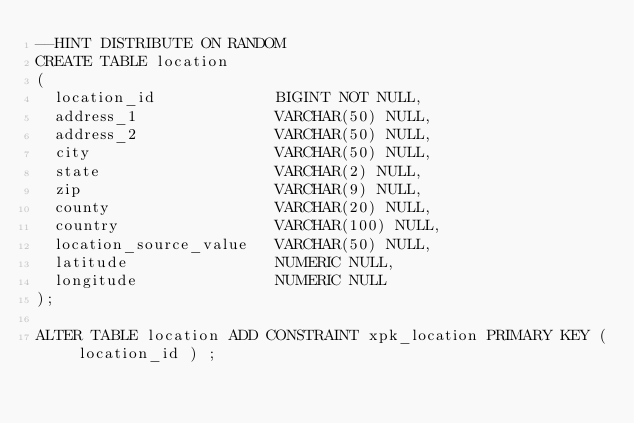Convert code to text. <code><loc_0><loc_0><loc_500><loc_500><_SQL_>--HINT DISTRIBUTE ON RANDOM
CREATE TABLE location
(
  location_id             BIGINT NOT NULL,
  address_1               VARCHAR(50) NULL,
  address_2               VARCHAR(50) NULL,
  city                    VARCHAR(50) NULL,
  state                   VARCHAR(2) NULL,
  zip                     VARCHAR(9) NULL,
  county                  VARCHAR(20) NULL,
  country                 VARCHAR(100) NULL,
  location_source_value   VARCHAR(50) NULL,
  latitude                NUMERIC NULL,
  longitude               NUMERIC NULL
);

ALTER TABLE location ADD CONSTRAINT xpk_location PRIMARY KEY ( location_id ) ;
</code> 